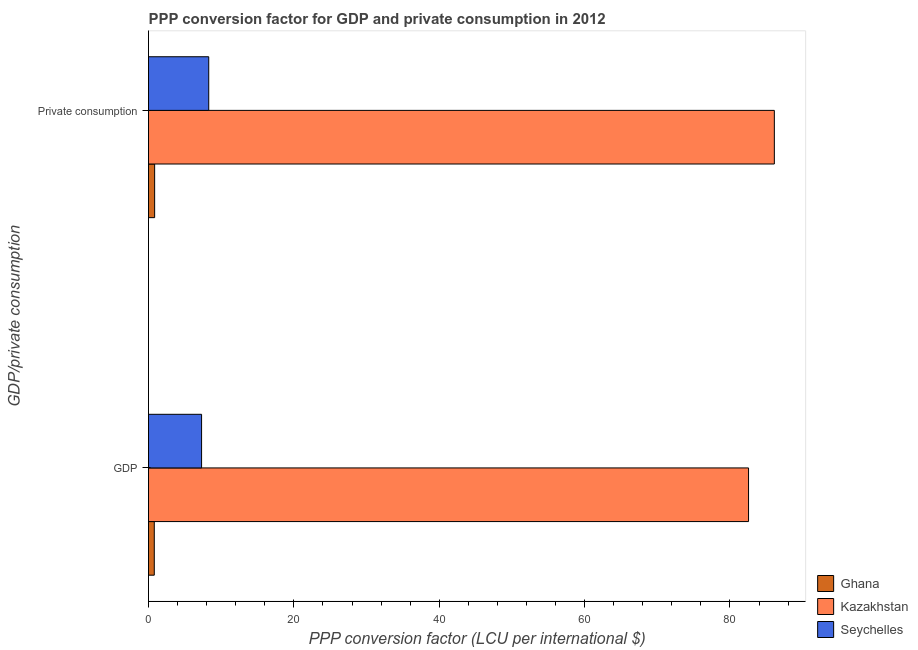Are the number of bars per tick equal to the number of legend labels?
Provide a short and direct response. Yes. How many bars are there on the 1st tick from the bottom?
Your answer should be very brief. 3. What is the label of the 2nd group of bars from the top?
Your answer should be very brief. GDP. What is the ppp conversion factor for private consumption in Seychelles?
Keep it short and to the point. 8.29. Across all countries, what is the maximum ppp conversion factor for gdp?
Offer a very short reply. 82.56. Across all countries, what is the minimum ppp conversion factor for private consumption?
Make the answer very short. 0.84. In which country was the ppp conversion factor for gdp maximum?
Offer a terse response. Kazakhstan. What is the total ppp conversion factor for private consumption in the graph?
Offer a terse response. 95.23. What is the difference between the ppp conversion factor for gdp in Kazakhstan and that in Ghana?
Make the answer very short. 81.76. What is the difference between the ppp conversion factor for gdp in Kazakhstan and the ppp conversion factor for private consumption in Seychelles?
Offer a terse response. 74.27. What is the average ppp conversion factor for private consumption per country?
Offer a terse response. 31.74. What is the difference between the ppp conversion factor for private consumption and ppp conversion factor for gdp in Seychelles?
Give a very brief answer. 0.98. What is the ratio of the ppp conversion factor for gdp in Ghana to that in Kazakhstan?
Provide a short and direct response. 0.01. Is the ppp conversion factor for gdp in Ghana less than that in Seychelles?
Give a very brief answer. Yes. In how many countries, is the ppp conversion factor for gdp greater than the average ppp conversion factor for gdp taken over all countries?
Your response must be concise. 1. What does the 3rd bar from the top in GDP represents?
Keep it short and to the point. Ghana. What does the 2nd bar from the bottom in GDP represents?
Your response must be concise. Kazakhstan. How many bars are there?
Offer a terse response. 6. Are all the bars in the graph horizontal?
Provide a short and direct response. Yes. Are the values on the major ticks of X-axis written in scientific E-notation?
Your answer should be very brief. No. Does the graph contain grids?
Your response must be concise. No. How are the legend labels stacked?
Ensure brevity in your answer.  Vertical. What is the title of the graph?
Provide a succinct answer. PPP conversion factor for GDP and private consumption in 2012. Does "American Samoa" appear as one of the legend labels in the graph?
Your answer should be very brief. No. What is the label or title of the X-axis?
Offer a very short reply. PPP conversion factor (LCU per international $). What is the label or title of the Y-axis?
Keep it short and to the point. GDP/private consumption. What is the PPP conversion factor (LCU per international $) in Ghana in GDP?
Provide a short and direct response. 0.79. What is the PPP conversion factor (LCU per international $) in Kazakhstan in GDP?
Offer a very short reply. 82.56. What is the PPP conversion factor (LCU per international $) of Seychelles in GDP?
Your answer should be very brief. 7.3. What is the PPP conversion factor (LCU per international $) of Ghana in  Private consumption?
Provide a succinct answer. 0.84. What is the PPP conversion factor (LCU per international $) of Kazakhstan in  Private consumption?
Your answer should be very brief. 86.11. What is the PPP conversion factor (LCU per international $) in Seychelles in  Private consumption?
Ensure brevity in your answer.  8.29. Across all GDP/private consumption, what is the maximum PPP conversion factor (LCU per international $) in Ghana?
Your response must be concise. 0.84. Across all GDP/private consumption, what is the maximum PPP conversion factor (LCU per international $) of Kazakhstan?
Ensure brevity in your answer.  86.11. Across all GDP/private consumption, what is the maximum PPP conversion factor (LCU per international $) in Seychelles?
Offer a very short reply. 8.29. Across all GDP/private consumption, what is the minimum PPP conversion factor (LCU per international $) of Ghana?
Your answer should be compact. 0.79. Across all GDP/private consumption, what is the minimum PPP conversion factor (LCU per international $) in Kazakhstan?
Your answer should be compact. 82.56. Across all GDP/private consumption, what is the minimum PPP conversion factor (LCU per international $) in Seychelles?
Make the answer very short. 7.3. What is the total PPP conversion factor (LCU per international $) in Ghana in the graph?
Keep it short and to the point. 1.63. What is the total PPP conversion factor (LCU per international $) in Kazakhstan in the graph?
Keep it short and to the point. 168.66. What is the total PPP conversion factor (LCU per international $) in Seychelles in the graph?
Make the answer very short. 15.59. What is the difference between the PPP conversion factor (LCU per international $) of Ghana in GDP and that in  Private consumption?
Make the answer very short. -0.05. What is the difference between the PPP conversion factor (LCU per international $) in Kazakhstan in GDP and that in  Private consumption?
Your answer should be compact. -3.55. What is the difference between the PPP conversion factor (LCU per international $) in Seychelles in GDP and that in  Private consumption?
Give a very brief answer. -0.98. What is the difference between the PPP conversion factor (LCU per international $) of Ghana in GDP and the PPP conversion factor (LCU per international $) of Kazakhstan in  Private consumption?
Offer a terse response. -85.31. What is the difference between the PPP conversion factor (LCU per international $) in Ghana in GDP and the PPP conversion factor (LCU per international $) in Seychelles in  Private consumption?
Your response must be concise. -7.49. What is the difference between the PPP conversion factor (LCU per international $) of Kazakhstan in GDP and the PPP conversion factor (LCU per international $) of Seychelles in  Private consumption?
Provide a succinct answer. 74.27. What is the average PPP conversion factor (LCU per international $) of Ghana per GDP/private consumption?
Make the answer very short. 0.82. What is the average PPP conversion factor (LCU per international $) in Kazakhstan per GDP/private consumption?
Make the answer very short. 84.33. What is the average PPP conversion factor (LCU per international $) of Seychelles per GDP/private consumption?
Ensure brevity in your answer.  7.79. What is the difference between the PPP conversion factor (LCU per international $) in Ghana and PPP conversion factor (LCU per international $) in Kazakhstan in GDP?
Provide a short and direct response. -81.76. What is the difference between the PPP conversion factor (LCU per international $) in Ghana and PPP conversion factor (LCU per international $) in Seychelles in GDP?
Your answer should be very brief. -6.51. What is the difference between the PPP conversion factor (LCU per international $) of Kazakhstan and PPP conversion factor (LCU per international $) of Seychelles in GDP?
Ensure brevity in your answer.  75.25. What is the difference between the PPP conversion factor (LCU per international $) of Ghana and PPP conversion factor (LCU per international $) of Kazakhstan in  Private consumption?
Provide a succinct answer. -85.26. What is the difference between the PPP conversion factor (LCU per international $) in Ghana and PPP conversion factor (LCU per international $) in Seychelles in  Private consumption?
Give a very brief answer. -7.44. What is the difference between the PPP conversion factor (LCU per international $) in Kazakhstan and PPP conversion factor (LCU per international $) in Seychelles in  Private consumption?
Your answer should be very brief. 77.82. What is the ratio of the PPP conversion factor (LCU per international $) of Ghana in GDP to that in  Private consumption?
Your response must be concise. 0.94. What is the ratio of the PPP conversion factor (LCU per international $) of Kazakhstan in GDP to that in  Private consumption?
Provide a succinct answer. 0.96. What is the ratio of the PPP conversion factor (LCU per international $) of Seychelles in GDP to that in  Private consumption?
Make the answer very short. 0.88. What is the difference between the highest and the second highest PPP conversion factor (LCU per international $) of Ghana?
Your response must be concise. 0.05. What is the difference between the highest and the second highest PPP conversion factor (LCU per international $) in Kazakhstan?
Give a very brief answer. 3.55. What is the difference between the highest and the second highest PPP conversion factor (LCU per international $) of Seychelles?
Your answer should be compact. 0.98. What is the difference between the highest and the lowest PPP conversion factor (LCU per international $) in Ghana?
Provide a succinct answer. 0.05. What is the difference between the highest and the lowest PPP conversion factor (LCU per international $) in Kazakhstan?
Offer a very short reply. 3.55. What is the difference between the highest and the lowest PPP conversion factor (LCU per international $) in Seychelles?
Make the answer very short. 0.98. 